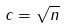Convert formula to latex. <formula><loc_0><loc_0><loc_500><loc_500>c = \sqrt { n }</formula> 